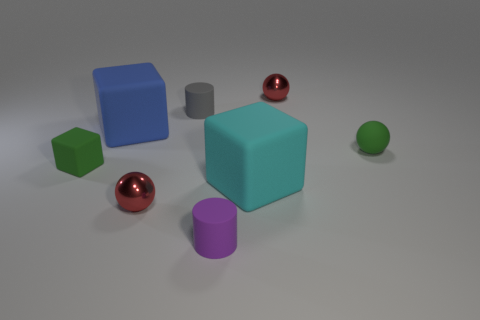What number of other objects are the same shape as the cyan matte thing?
Your answer should be compact. 2. There is a green rubber cube; is its size the same as the blue block that is behind the large cyan matte thing?
Make the answer very short. No. What number of objects are red spheres on the left side of the tiny purple rubber cylinder or large matte objects?
Your answer should be very brief. 3. There is a large matte object to the right of the blue matte object; what shape is it?
Keep it short and to the point. Cube. Is the number of big things that are in front of the purple cylinder the same as the number of small green objects that are to the right of the small green sphere?
Give a very brief answer. Yes. The rubber thing that is on the left side of the purple matte cylinder and right of the large blue block is what color?
Make the answer very short. Gray. There is a red object that is in front of the thing left of the big blue rubber thing; what is it made of?
Offer a terse response. Metal. Does the green cube have the same size as the cyan matte object?
Offer a terse response. No. What number of small objects are green blocks or rubber cylinders?
Ensure brevity in your answer.  3. There is a small gray rubber cylinder; what number of gray matte cylinders are to the right of it?
Provide a short and direct response. 0. 